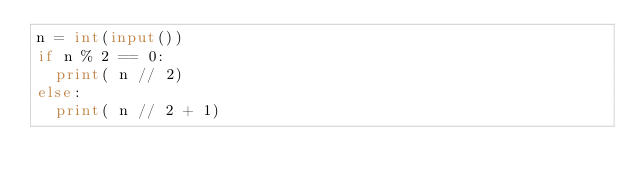<code> <loc_0><loc_0><loc_500><loc_500><_Python_>n = int(input())
if n % 2 == 0:
  print( n // 2)
else:
  print( n // 2 + 1)</code> 